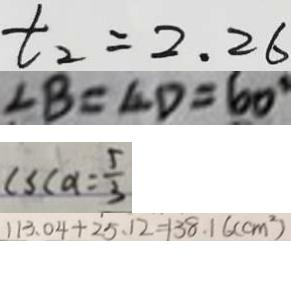Convert formula to latex. <formula><loc_0><loc_0><loc_500><loc_500>t _ { 2 } = 2 . 2 6 
 \angle B = \angle D = 6 0 ^ { \circ } 
 c s c a = \frac { 5 } { 3 } 
 1 1 3 . 0 4 + 2 5 . 1 2 = 1 3 8 . 1 6 ( c m ^ { 2 } )</formula> 